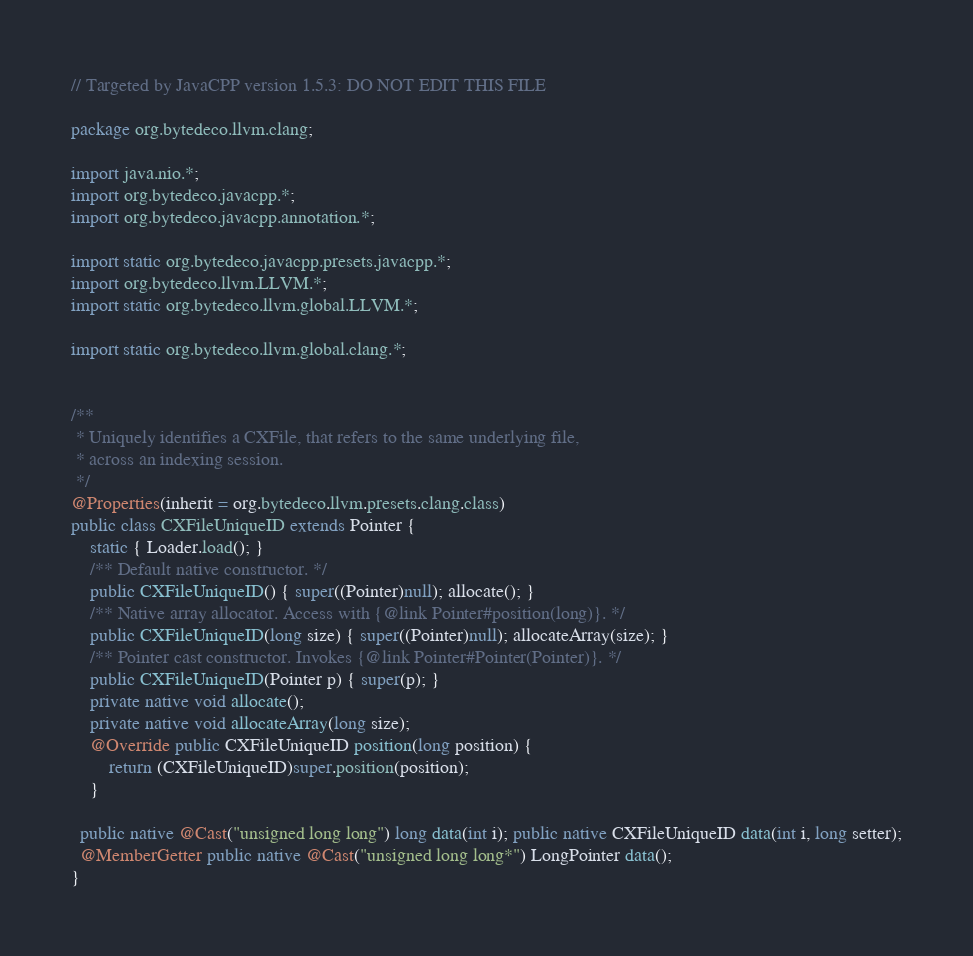Convert code to text. <code><loc_0><loc_0><loc_500><loc_500><_Java_>// Targeted by JavaCPP version 1.5.3: DO NOT EDIT THIS FILE

package org.bytedeco.llvm.clang;

import java.nio.*;
import org.bytedeco.javacpp.*;
import org.bytedeco.javacpp.annotation.*;

import static org.bytedeco.javacpp.presets.javacpp.*;
import org.bytedeco.llvm.LLVM.*;
import static org.bytedeco.llvm.global.LLVM.*;

import static org.bytedeco.llvm.global.clang.*;


/**
 * Uniquely identifies a CXFile, that refers to the same underlying file,
 * across an indexing session.
 */
@Properties(inherit = org.bytedeco.llvm.presets.clang.class)
public class CXFileUniqueID extends Pointer {
    static { Loader.load(); }
    /** Default native constructor. */
    public CXFileUniqueID() { super((Pointer)null); allocate(); }
    /** Native array allocator. Access with {@link Pointer#position(long)}. */
    public CXFileUniqueID(long size) { super((Pointer)null); allocateArray(size); }
    /** Pointer cast constructor. Invokes {@link Pointer#Pointer(Pointer)}. */
    public CXFileUniqueID(Pointer p) { super(p); }
    private native void allocate();
    private native void allocateArray(long size);
    @Override public CXFileUniqueID position(long position) {
        return (CXFileUniqueID)super.position(position);
    }

  public native @Cast("unsigned long long") long data(int i); public native CXFileUniqueID data(int i, long setter);
  @MemberGetter public native @Cast("unsigned long long*") LongPointer data();
}
</code> 